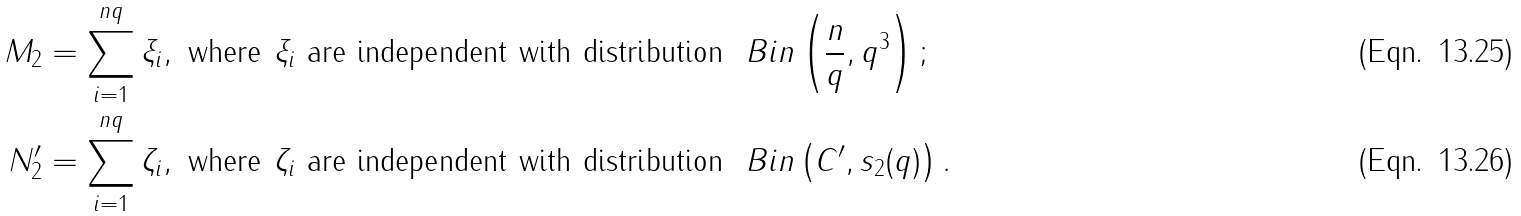<formula> <loc_0><loc_0><loc_500><loc_500>M _ { 2 } & = \sum _ { i = 1 } ^ { n q } \xi _ { i } , \text { where $\xi_{i}$ are independent with distribution } \ B i n \left ( \frac { n } { q } , q ^ { 3 } \right ) ; \\ N _ { 2 } ^ { \prime } & = \sum _ { i = 1 } ^ { n q } \zeta _ { i } , \text { where $\zeta_{i}$ are independent with distribution } \ B i n \left ( C ^ { \prime } , s _ { 2 } ( q ) \right ) .</formula> 